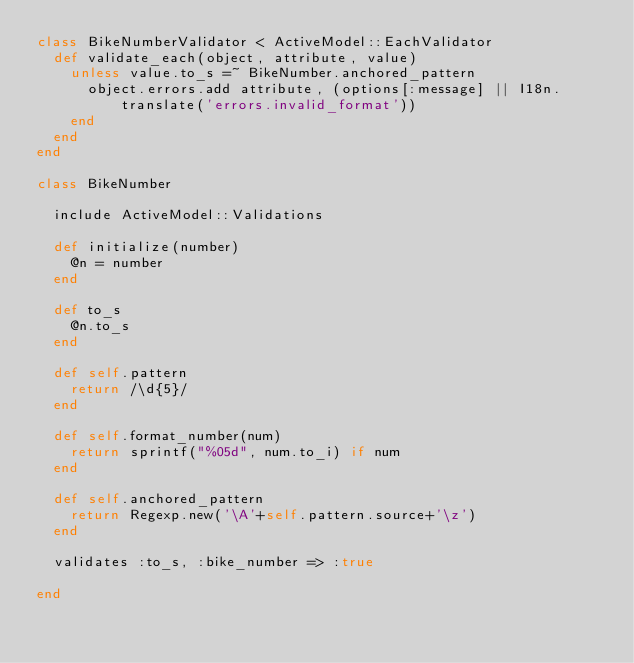Convert code to text. <code><loc_0><loc_0><loc_500><loc_500><_Ruby_>class BikeNumberValidator < ActiveModel::EachValidator
  def validate_each(object, attribute, value)
    unless value.to_s =~ BikeNumber.anchored_pattern
      object.errors.add attribute, (options[:message] || I18n.translate('errors.invalid_format'))
    end 
  end
end

class BikeNumber

  include ActiveModel::Validations

  def initialize(number)
    @n = number
  end

  def to_s
    @n.to_s
  end

  def self.pattern
    return /\d{5}/
  end

  def self.format_number(num)
    return sprintf("%05d", num.to_i) if num
  end

  def self.anchored_pattern
    return Regexp.new('\A'+self.pattern.source+'\z')
  end

  validates :to_s, :bike_number => :true

end
</code> 